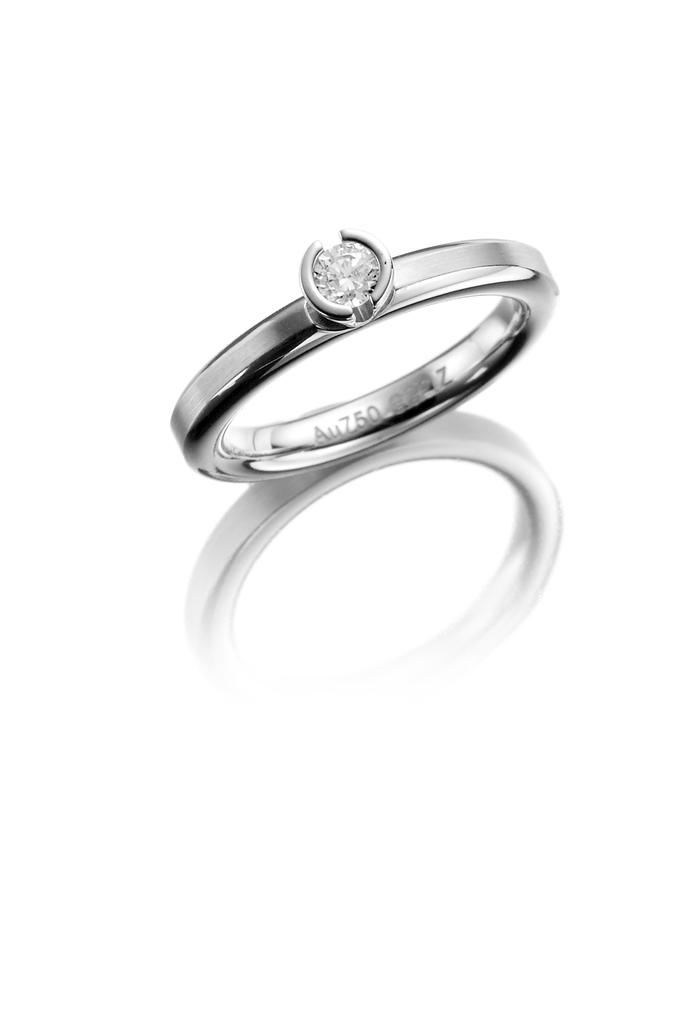What is the main object in the image? There is a ring in the image. What is the most prominent feature of the ring? The ring has a diamond. Where is the ring located in the image? The ring is placed on a surface. What type of cream is being served at the airport in the image? There is no airport or cream present in the image; it only features a ring with a diamond on a surface. 